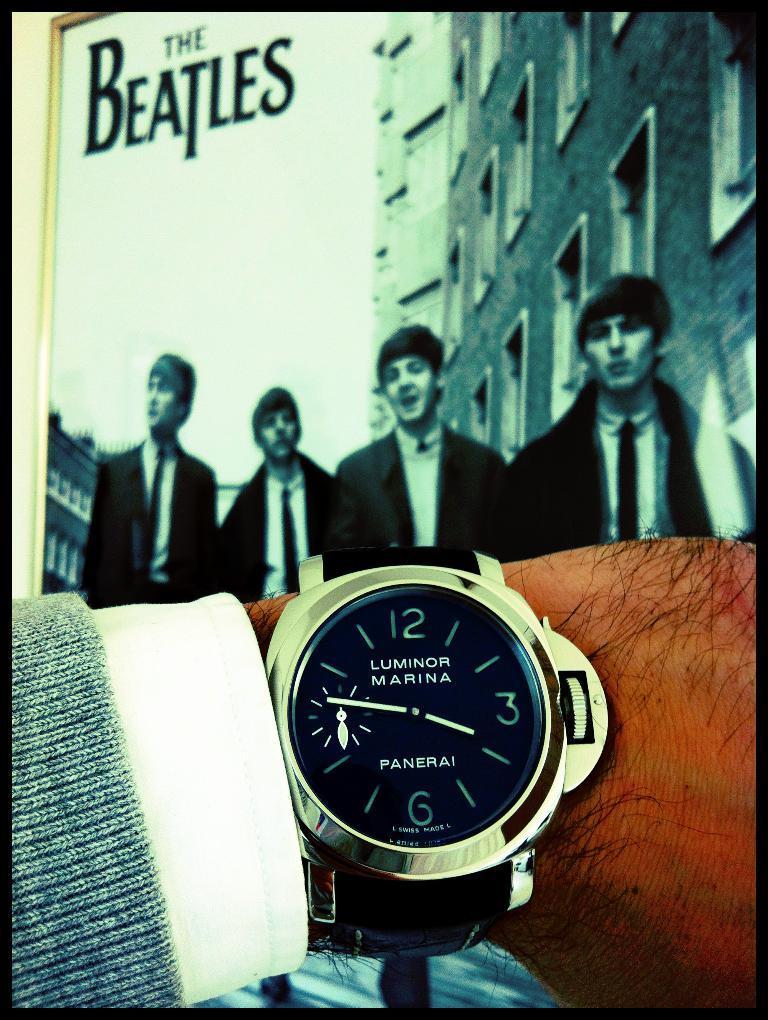How would you summarize this image in a sentence or two? In this image there is a watch which is on the hand. In the background there is a photo frame in which there are four boys. Behind them there are buildings. 